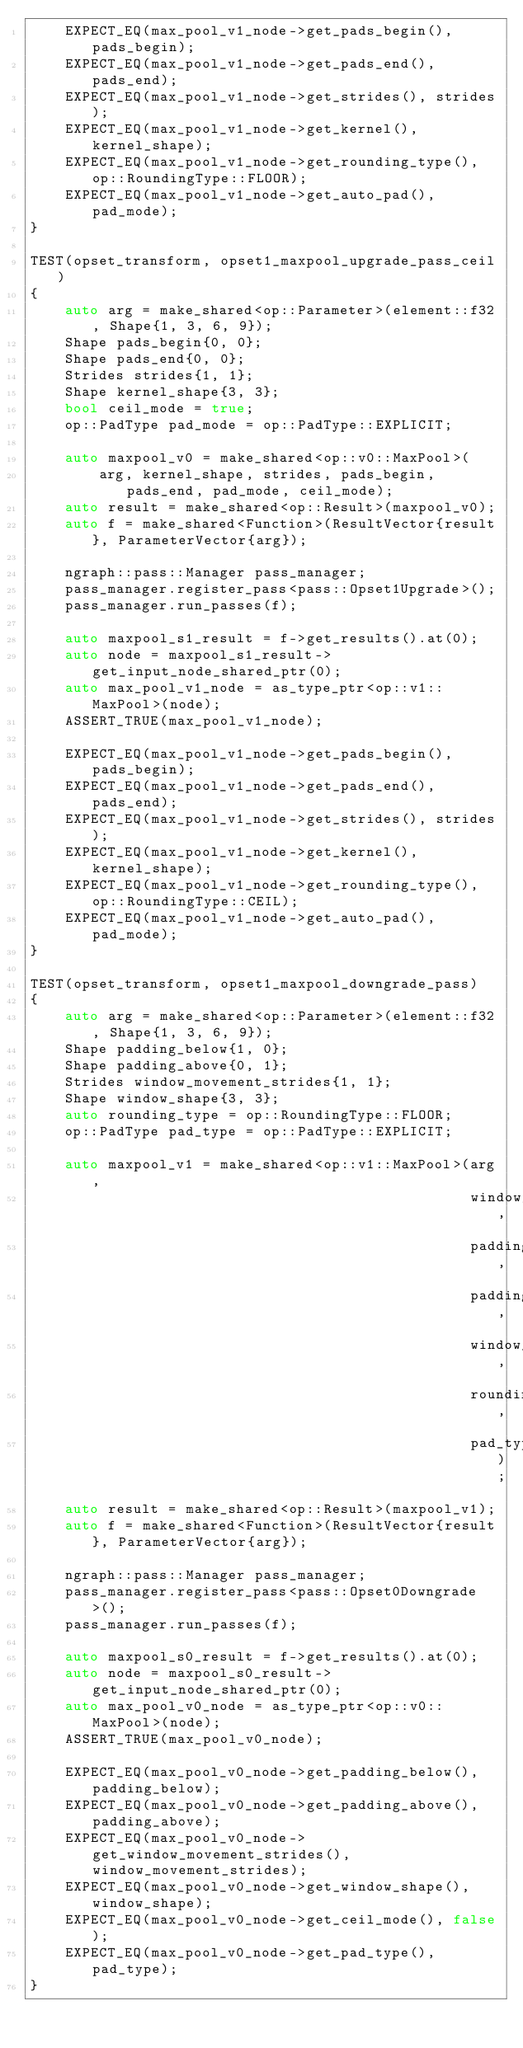Convert code to text. <code><loc_0><loc_0><loc_500><loc_500><_C++_>    EXPECT_EQ(max_pool_v1_node->get_pads_begin(), pads_begin);
    EXPECT_EQ(max_pool_v1_node->get_pads_end(), pads_end);
    EXPECT_EQ(max_pool_v1_node->get_strides(), strides);
    EXPECT_EQ(max_pool_v1_node->get_kernel(), kernel_shape);
    EXPECT_EQ(max_pool_v1_node->get_rounding_type(), op::RoundingType::FLOOR);
    EXPECT_EQ(max_pool_v1_node->get_auto_pad(), pad_mode);
}

TEST(opset_transform, opset1_maxpool_upgrade_pass_ceil)
{
    auto arg = make_shared<op::Parameter>(element::f32, Shape{1, 3, 6, 9});
    Shape pads_begin{0, 0};
    Shape pads_end{0, 0};
    Strides strides{1, 1};
    Shape kernel_shape{3, 3};
    bool ceil_mode = true;
    op::PadType pad_mode = op::PadType::EXPLICIT;

    auto maxpool_v0 = make_shared<op::v0::MaxPool>(
        arg, kernel_shape, strides, pads_begin, pads_end, pad_mode, ceil_mode);
    auto result = make_shared<op::Result>(maxpool_v0);
    auto f = make_shared<Function>(ResultVector{result}, ParameterVector{arg});

    ngraph::pass::Manager pass_manager;
    pass_manager.register_pass<pass::Opset1Upgrade>();
    pass_manager.run_passes(f);

    auto maxpool_s1_result = f->get_results().at(0);
    auto node = maxpool_s1_result->get_input_node_shared_ptr(0);
    auto max_pool_v1_node = as_type_ptr<op::v1::MaxPool>(node);
    ASSERT_TRUE(max_pool_v1_node);

    EXPECT_EQ(max_pool_v1_node->get_pads_begin(), pads_begin);
    EXPECT_EQ(max_pool_v1_node->get_pads_end(), pads_end);
    EXPECT_EQ(max_pool_v1_node->get_strides(), strides);
    EXPECT_EQ(max_pool_v1_node->get_kernel(), kernel_shape);
    EXPECT_EQ(max_pool_v1_node->get_rounding_type(), op::RoundingType::CEIL);
    EXPECT_EQ(max_pool_v1_node->get_auto_pad(), pad_mode);
}

TEST(opset_transform, opset1_maxpool_downgrade_pass)
{
    auto arg = make_shared<op::Parameter>(element::f32, Shape{1, 3, 6, 9});
    Shape padding_below{1, 0};
    Shape padding_above{0, 1};
    Strides window_movement_strides{1, 1};
    Shape window_shape{3, 3};
    auto rounding_type = op::RoundingType::FLOOR;
    op::PadType pad_type = op::PadType::EXPLICIT;

    auto maxpool_v1 = make_shared<op::v1::MaxPool>(arg,
                                                   window_movement_strides,
                                                   padding_below,
                                                   padding_above,
                                                   window_shape,
                                                   rounding_type,
                                                   pad_type);
    auto result = make_shared<op::Result>(maxpool_v1);
    auto f = make_shared<Function>(ResultVector{result}, ParameterVector{arg});

    ngraph::pass::Manager pass_manager;
    pass_manager.register_pass<pass::Opset0Downgrade>();
    pass_manager.run_passes(f);

    auto maxpool_s0_result = f->get_results().at(0);
    auto node = maxpool_s0_result->get_input_node_shared_ptr(0);
    auto max_pool_v0_node = as_type_ptr<op::v0::MaxPool>(node);
    ASSERT_TRUE(max_pool_v0_node);

    EXPECT_EQ(max_pool_v0_node->get_padding_below(), padding_below);
    EXPECT_EQ(max_pool_v0_node->get_padding_above(), padding_above);
    EXPECT_EQ(max_pool_v0_node->get_window_movement_strides(), window_movement_strides);
    EXPECT_EQ(max_pool_v0_node->get_window_shape(), window_shape);
    EXPECT_EQ(max_pool_v0_node->get_ceil_mode(), false);
    EXPECT_EQ(max_pool_v0_node->get_pad_type(), pad_type);
}
</code> 